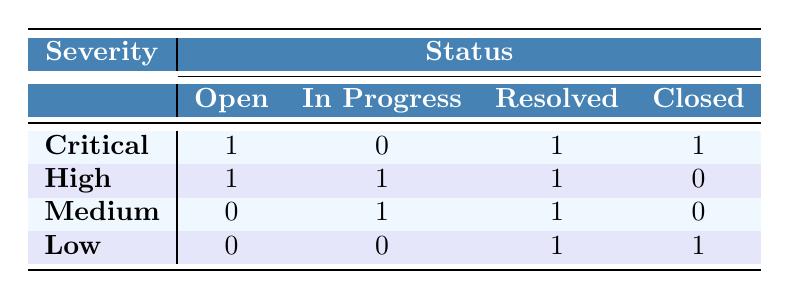What is the total number of Critical bugs? By looking at the Critical row in the table, we can see that there are 1 Open, 0 In Progress, 1 Resolved, and 1 Closed. Summing them gives 1 + 0 + 1 + 1 = 3.
Answer: 3 How many bugs are in the Resolved status? To find the total number of Resolved bugs, we check each row under the Resolved column: Critical has 1, High has 1, Medium has 1, and Low has 1. Adding these gives 1 + 1 + 1 + 1 = 4.
Answer: 4 Are there any Low severity bugs that are still Open? Checking the Low severity row, there's a count of 0 in the Open column, which means there are no Low severity bugs that are Open.
Answer: No Which severity has the highest count of bugs in the In Progress status? Observing the In Progress column, Critical has 0, High has 1, Medium has 1, and Low has 0. The highest count in this column is 1 for both High and Medium.
Answer: High and Medium What is the total number of Open bugs across all severities? For the Open status, we look at the counts: Critical has 1, High has 1, Medium has 0, and Low has 0. The total is 1 + 1 + 0 + 0 = 2.
Answer: 2 Are all Critical bugs resolved or closed? Looking at the Critical row: it has 1 Open, 0 In Progress, 1 Resolved, and 1 Closed. Since there is 1 Open bug, not all Critical bugs are resolved or closed.
Answer: No What is the difference in the number of High and Low severity bugs in the Closed status? The Closed status counts reveal Critical has 1, High has 0, Medium has 0, and Low has 1. The difference between High (0) and Low (1) is 1 - 0 = 1.
Answer: 1 Which severity has the least number of Open bugs? The Open counts are: Critical has 1, High has 1, Medium has 0, and Low has 0. The least number of Open bugs is 0, which is present in Medium and Low.
Answer: Medium and Low 